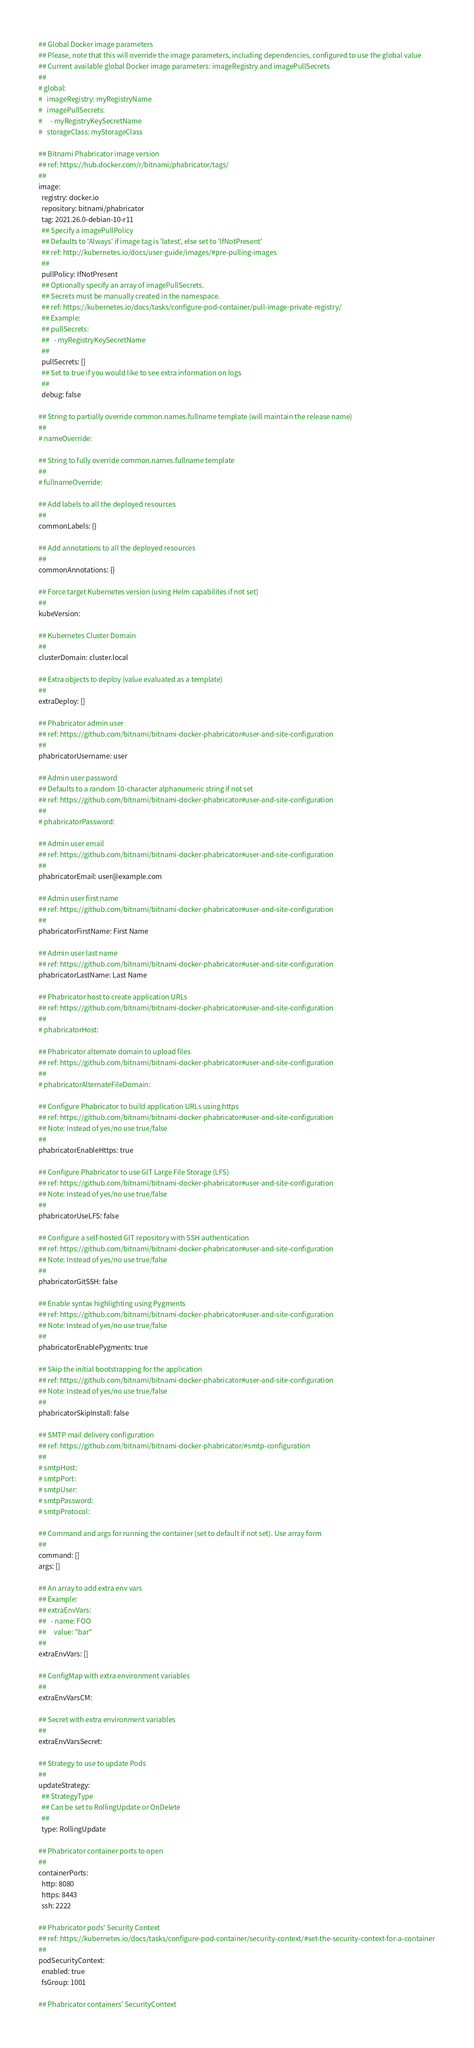<code> <loc_0><loc_0><loc_500><loc_500><_YAML_>## Global Docker image parameters
## Please, note that this will override the image parameters, including dependencies, configured to use the global value
## Current available global Docker image parameters: imageRegistry and imagePullSecrets
##
# global:
#   imageRegistry: myRegistryName
#   imagePullSecrets:
#     - myRegistryKeySecretName
#   storageClass: myStorageClass

## Bitnami Phabricator image version
## ref: https://hub.docker.com/r/bitnami/phabricator/tags/
##
image:
  registry: docker.io
  repository: bitnami/phabricator
  tag: 2021.26.0-debian-10-r11
  ## Specify a imagePullPolicy
  ## Defaults to 'Always' if image tag is 'latest', else set to 'IfNotPresent'
  ## ref: http://kubernetes.io/docs/user-guide/images/#pre-pulling-images
  ##
  pullPolicy: IfNotPresent
  ## Optionally specify an array of imagePullSecrets.
  ## Secrets must be manually created in the namespace.
  ## ref: https://kubernetes.io/docs/tasks/configure-pod-container/pull-image-private-registry/
  ## Example:
  ## pullSecrets:
  ##   - myRegistryKeySecretName
  ##
  pullSecrets: []
  ## Set to true if you would like to see extra information on logs
  ##
  debug: false

## String to partially override common.names.fullname template (will maintain the release name)
##
# nameOverride:

## String to fully override common.names.fullname template
##
# fullnameOverride:

## Add labels to all the deployed resources
##
commonLabels: {}

## Add annotations to all the deployed resources
##
commonAnnotations: {}

## Force target Kubernetes version (using Helm capabilites if not set)
##
kubeVersion:

## Kubernetes Cluster Domain
##
clusterDomain: cluster.local

## Extra objects to deploy (value evaluated as a template)
##
extraDeploy: []

## Phabricator admin user
## ref: https://github.com/bitnami/bitnami-docker-phabricator#user-and-site-configuration
##
phabricatorUsername: user

## Admin user password
## Defaults to a random 10-character alphanumeric string if not set
## ref: https://github.com/bitnami/bitnami-docker-phabricator#user-and-site-configuration
##
# phabricatorPassword:

## Admin user email
## ref: https://github.com/bitnami/bitnami-docker-phabricator#user-and-site-configuration
##
phabricatorEmail: user@example.com

## Admin user first name
## ref: https://github.com/bitnami/bitnami-docker-phabricator#user-and-site-configuration
##
phabricatorFirstName: First Name

## Admin user last name
## ref: https://github.com/bitnami/bitnami-docker-phabricator#user-and-site-configuration
phabricatorLastName: Last Name

## Phabricator host to create application URLs
## ref: https://github.com/bitnami/bitnami-docker-phabricator#user-and-site-configuration
##
# phabricatorHost:

## Phabricator alternate domain to upload files
## ref: https://github.com/bitnami/bitnami-docker-phabricator#user-and-site-configuration
##
# phabricatorAlternateFileDomain:

## Configure Phabricator to build application URLs using https
## ref: https://github.com/bitnami/bitnami-docker-phabricator#user-and-site-configuration
## Note: Instead of yes/no use true/false
##
phabricatorEnableHttps: true

## Configure Phabricator to use GIT Large File Storage (LFS)
## ref: https://github.com/bitnami/bitnami-docker-phabricator#user-and-site-configuration
## Note: Instead of yes/no use true/false
##
phabricatorUseLFS: false

## Configure a self-hosted GIT repository with SSH authentication
## ref: https://github.com/bitnami/bitnami-docker-phabricator#user-and-site-configuration
## Note: Instead of yes/no use true/false
##
phabricatorGitSSH: false

## Enable syntax highlighting using Pygments
## ref: https://github.com/bitnami/bitnami-docker-phabricator#user-and-site-configuration
## Note: Instead of yes/no use true/false
##
phabricatorEnablePygments: true

## Skip the initial bootstrapping for the application
## ref: https://github.com/bitnami/bitnami-docker-phabricator#user-and-site-configuration
## Note: Instead of yes/no use true/false
##
phabricatorSkipInstall: false

## SMTP mail delivery configuration
## ref: https://github.com/bitnami/bitnami-docker-phabricator/#smtp-configuration
##
# smtpHost:
# smtpPort:
# smtpUser:
# smtpPassword:
# smtpProtocol:

## Command and args for running the container (set to default if not set). Use array form
##
command: []
args: []

## An array to add extra env vars
## Example:
## extraEnvVars:
##   - name: FOO
##     value: "bar"
##
extraEnvVars: []

## ConfigMap with extra environment variables
##
extraEnvVarsCM:

## Secret with extra environment variables
##
extraEnvVarsSecret:

## Strategy to use to update Pods
##
updateStrategy:
  ## StrategyType
  ## Can be set to RollingUpdate or OnDelete
  ##
  type: RollingUpdate

## Phabricator container ports to open
##
containerPorts:
  http: 8080
  https: 8443
  ssh: 2222

## Phabricator pods' Security Context
## ref: https://kubernetes.io/docs/tasks/configure-pod-container/security-context/#set-the-security-context-for-a-container
##
podSecurityContext:
  enabled: true
  fsGroup: 1001

## Phabricator containers' SecurityContext</code> 